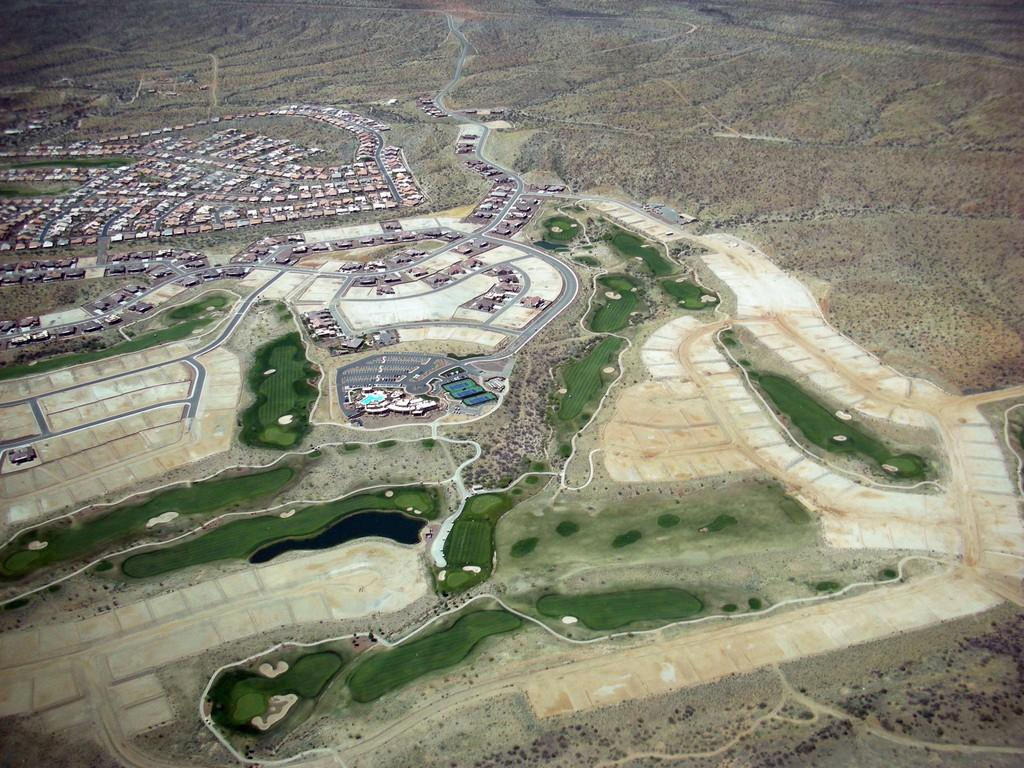What type of view is shown in the image? The image is an aerial view. What structures can be seen from this perspective? There are buildings visible in the image. What else can be seen in the image besides buildings? There are roads and water visible in the image. What type of cake is being judged in the image? There is no cake or judge present in the image. 